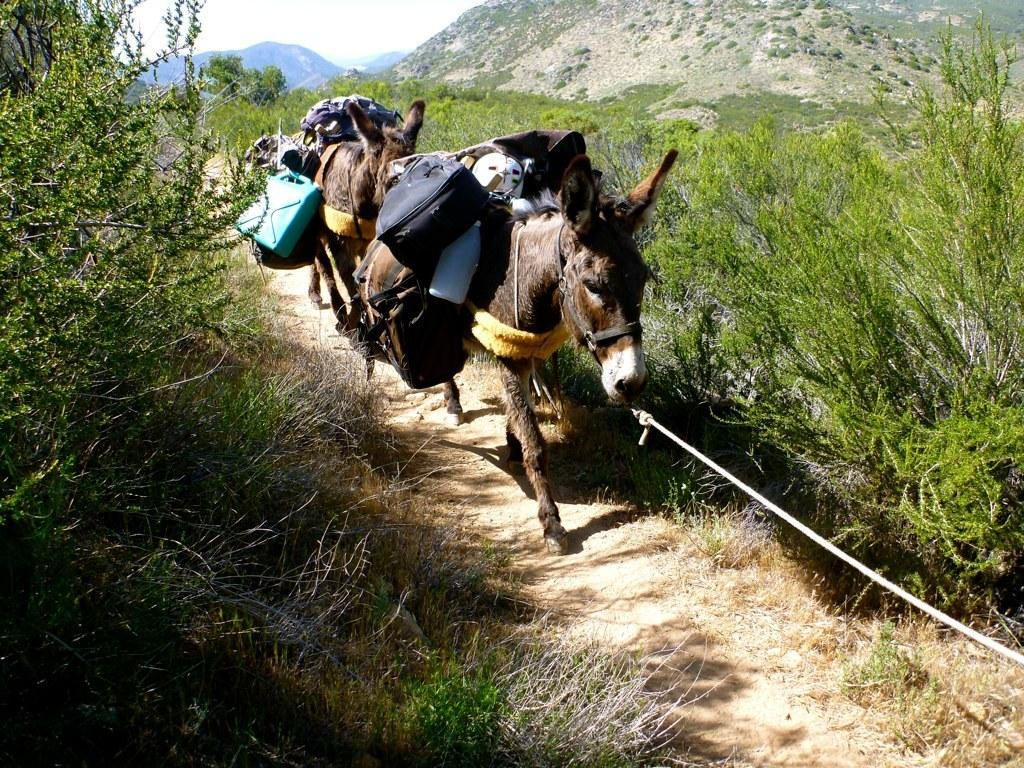How many donkeys are in the image? There are two donkeys in the image. What is located on either side of the donkeys? There are plants on either side of the donkeys. What can be seen in the background of the image? There is a mountain visible in the background of the image. What type of surprise can be seen on the donkeys' faces in the image? There are no expressions or surprises visible on the donkeys' faces in the image. 